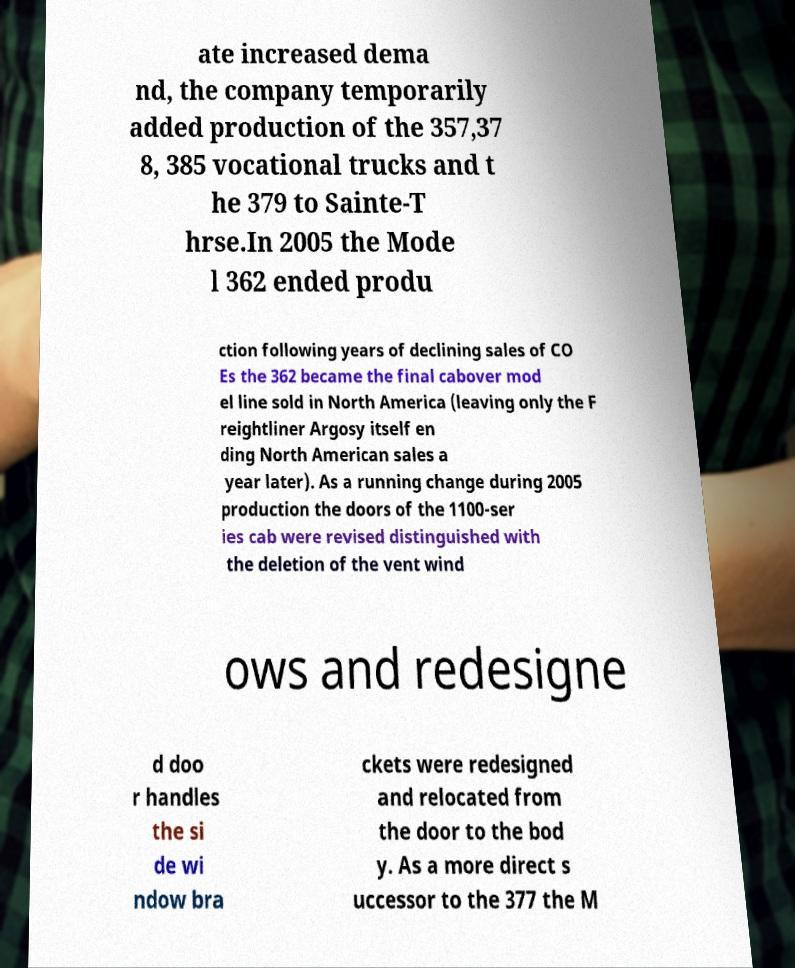For documentation purposes, I need the text within this image transcribed. Could you provide that? ate increased dema nd, the company temporarily added production of the 357,37 8, 385 vocational trucks and t he 379 to Sainte-T hrse.In 2005 the Mode l 362 ended produ ction following years of declining sales of CO Es the 362 became the final cabover mod el line sold in North America (leaving only the F reightliner Argosy itself en ding North American sales a year later). As a running change during 2005 production the doors of the 1100-ser ies cab were revised distinguished with the deletion of the vent wind ows and redesigne d doo r handles the si de wi ndow bra ckets were redesigned and relocated from the door to the bod y. As a more direct s uccessor to the 377 the M 